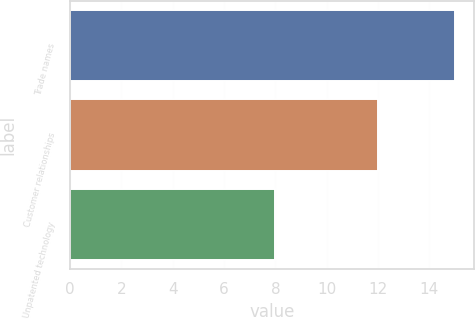Convert chart to OTSL. <chart><loc_0><loc_0><loc_500><loc_500><bar_chart><fcel>Trade names<fcel>Customer relationships<fcel>Unpatented technology<nl><fcel>15<fcel>12<fcel>8<nl></chart> 